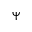Convert formula to latex. <formula><loc_0><loc_0><loc_500><loc_500>\Psi</formula> 